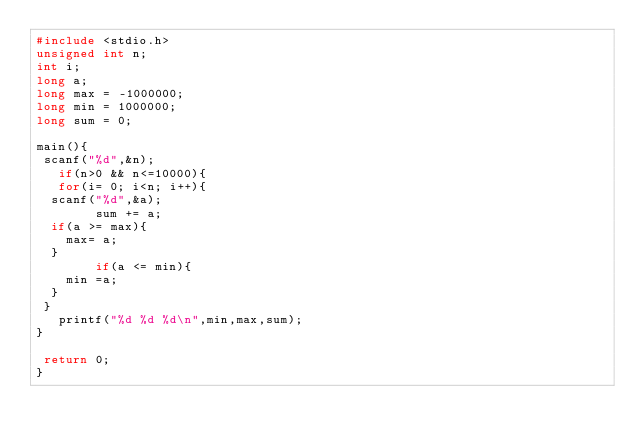Convert code to text. <code><loc_0><loc_0><loc_500><loc_500><_C_>#include <stdio.h>
unsigned int n;
int i;
long a;
long max = -1000000;
long min = 1000000;
long sum = 0;

main(){
 scanf("%d",&n);
   if(n>0 && n<=10000){
   for(i= 0; i<n; i++){
 	scanf("%d",&a);
        sum += a;
 	if(a >= max){
 		max= a;
 	}
        if(a <= min){
 		min =a;
 	}
 }
   printf("%d %d %d\n",min,max,sum);
}

 return 0;
}</code> 